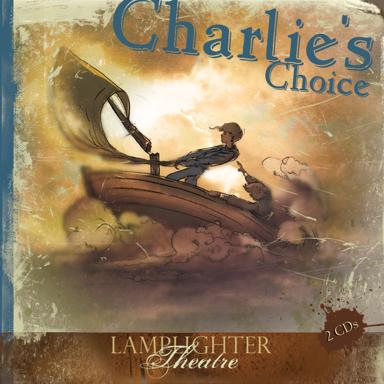Can you tell me the title of the book mentioned in the image? The book featured in the image is titled 'Charlie's Choice,' produced by Lamplighter Theatre and available on 2 audio CDs. This dramatic audio brings to life an engaging story that captures the imagination. 